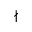<formula> <loc_0><loc_0><loc_500><loc_500>\nmid</formula> 